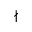<formula> <loc_0><loc_0><loc_500><loc_500>\nmid</formula> 